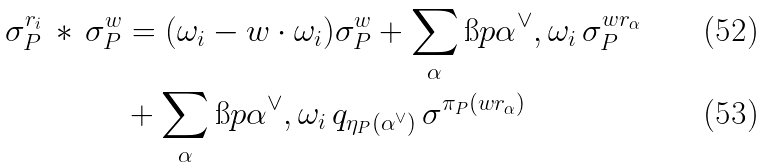<formula> <loc_0><loc_0><loc_500><loc_500>\sigma _ { P } ^ { r _ { i } } \, * \, \sigma _ { P } ^ { w } & = ( \omega _ { i } - w \cdot \omega _ { i } ) \sigma _ { P } ^ { w } + \sum _ { \alpha } \i p { \alpha ^ { \vee } , \omega _ { i } } \, \sigma _ { P } ^ { w r _ { \alpha } } \\ & + \sum _ { \alpha } \i p { \alpha ^ { \vee } , \omega _ { i } } \, q _ { \eta _ { P } ( \alpha ^ { \vee } ) } \, \sigma ^ { \pi _ { P } ( w r _ { \alpha } ) }</formula> 